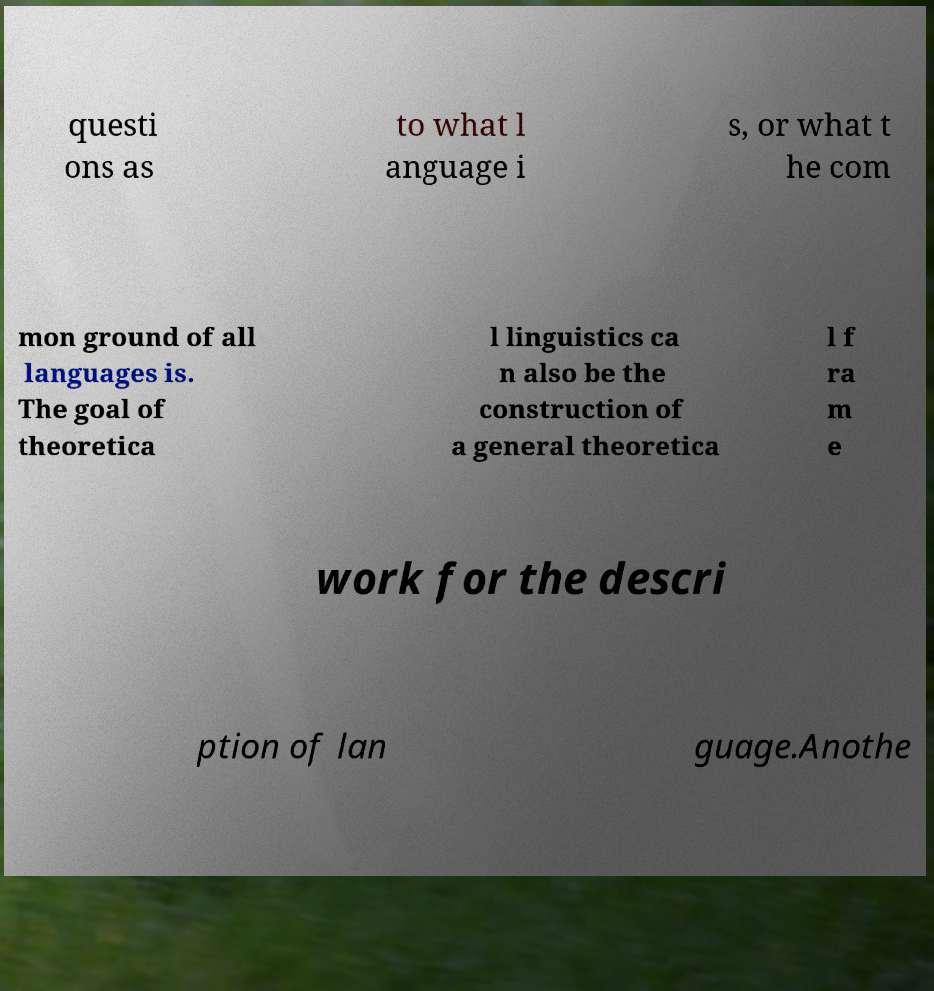For documentation purposes, I need the text within this image transcribed. Could you provide that? questi ons as to what l anguage i s, or what t he com mon ground of all languages is. The goal of theoretica l linguistics ca n also be the construction of a general theoretica l f ra m e work for the descri ption of lan guage.Anothe 